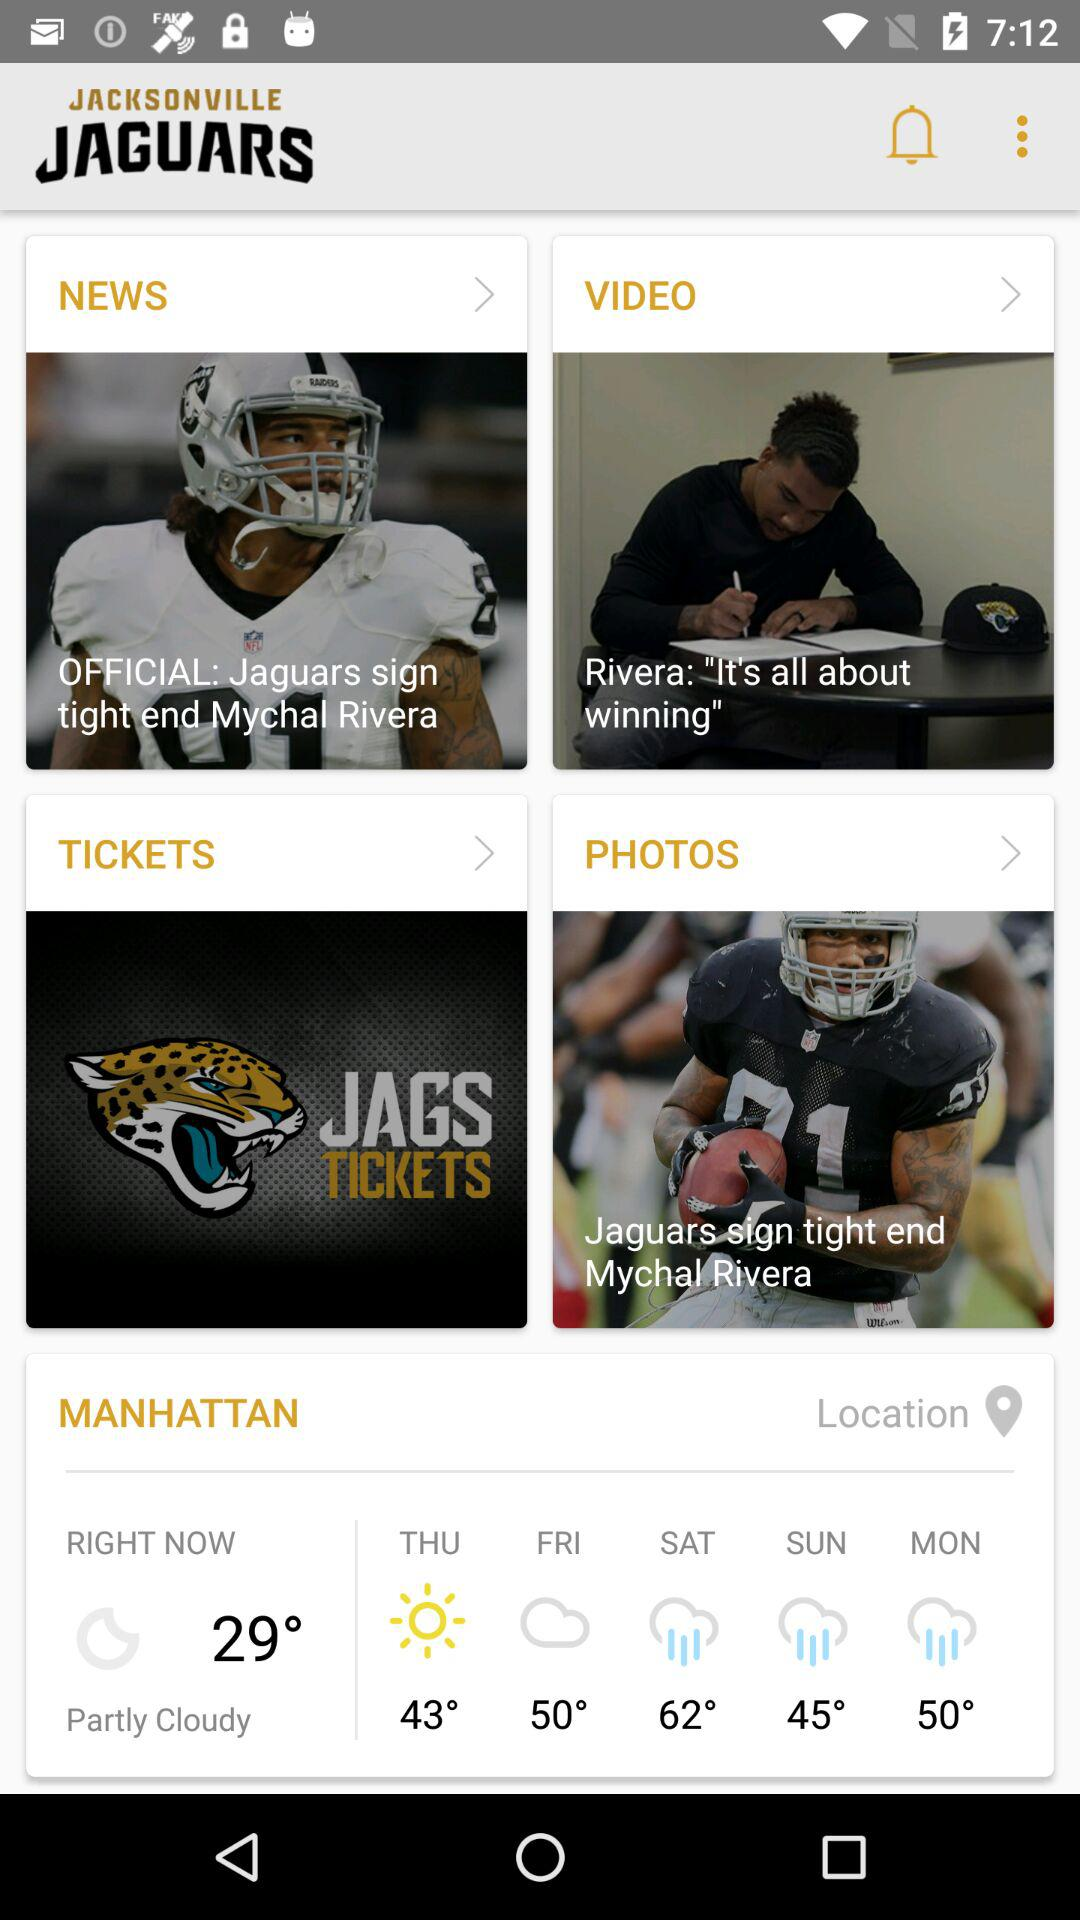What is the forecast for Monday? The forecast for Monday is 50°. 